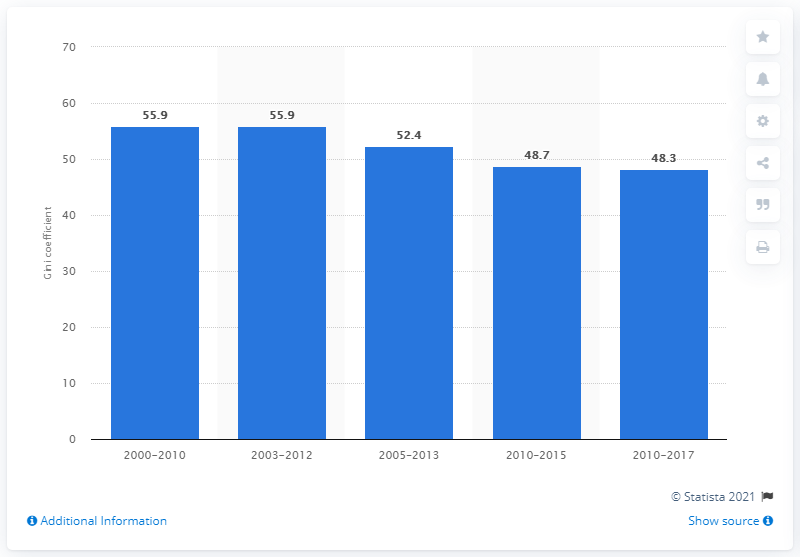Highlight a few significant elements in this photo. The Gini coefficient in Guatemala as of 2017 was 48.3, indicating a moderate level of income inequality in the country. 